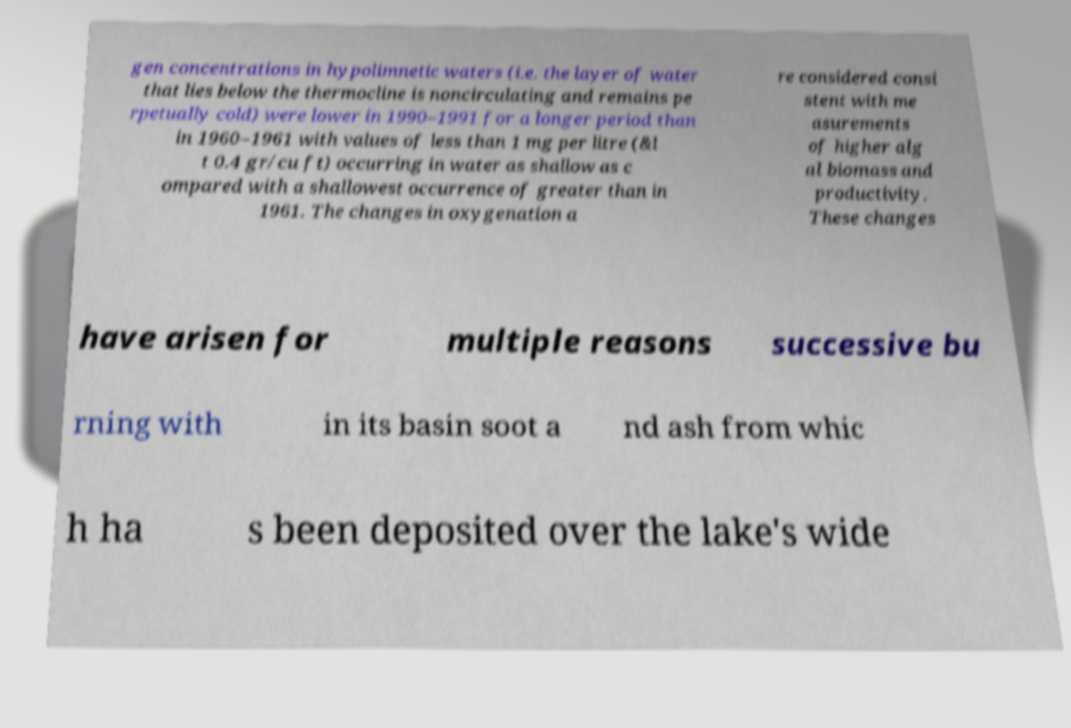Could you extract and type out the text from this image? gen concentrations in hypolimnetic waters (i.e. the layer of water that lies below the thermocline is noncirculating and remains pe rpetually cold) were lower in 1990–1991 for a longer period than in 1960–1961 with values of less than 1 mg per litre (&l t 0.4 gr/cu ft) occurring in water as shallow as c ompared with a shallowest occurrence of greater than in 1961. The changes in oxygenation a re considered consi stent with me asurements of higher alg al biomass and productivity. These changes have arisen for multiple reasons successive bu rning with in its basin soot a nd ash from whic h ha s been deposited over the lake's wide 